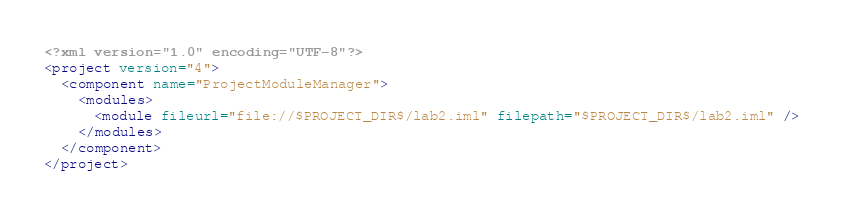Convert code to text. <code><loc_0><loc_0><loc_500><loc_500><_XML_><?xml version="1.0" encoding="UTF-8"?>
<project version="4">
  <component name="ProjectModuleManager">
    <modules>
      <module fileurl="file://$PROJECT_DIR$/lab2.iml" filepath="$PROJECT_DIR$/lab2.iml" />
    </modules>
  </component>
</project></code> 